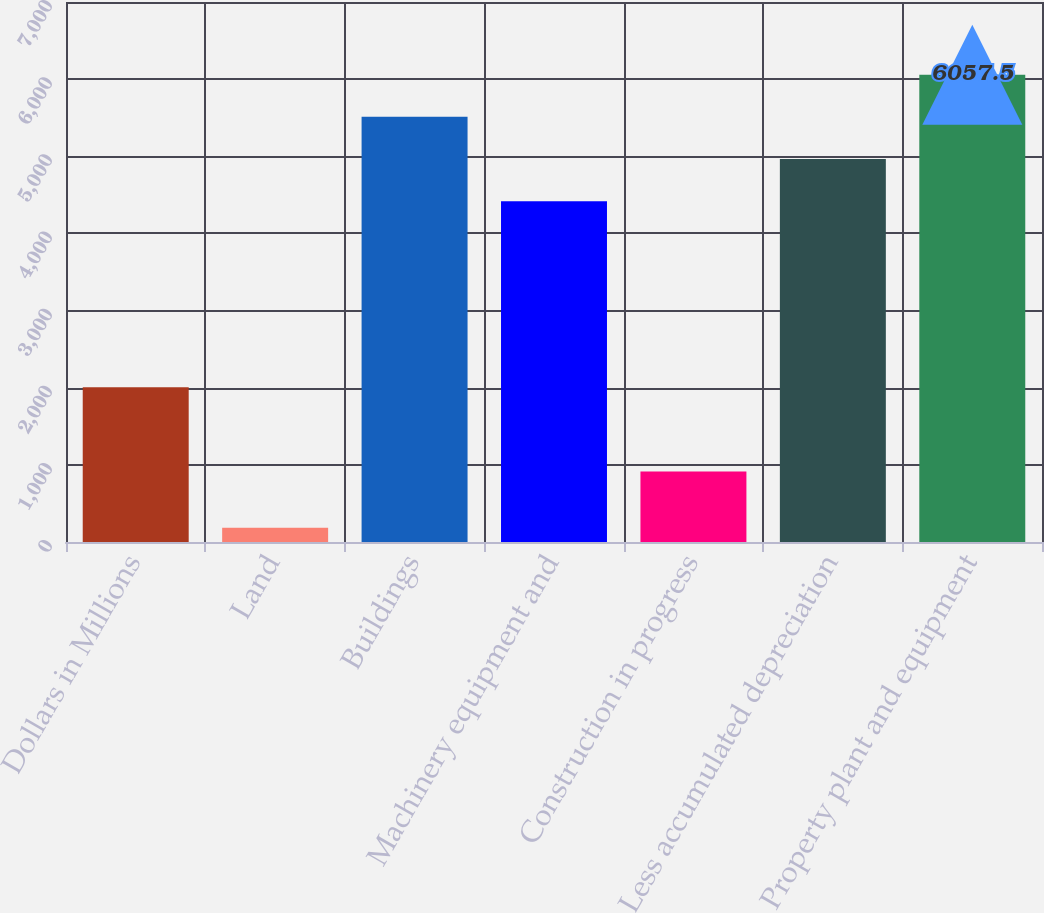Convert chart to OTSL. <chart><loc_0><loc_0><loc_500><loc_500><bar_chart><fcel>Dollars in Millions<fcel>Land<fcel>Buildings<fcel>Machinery equipment and<fcel>Construction in progress<fcel>Less accumulated depreciation<fcel>Property plant and equipment<nl><fcel>2007<fcel>185<fcel>5511<fcel>4418<fcel>915<fcel>4964.5<fcel>6057.5<nl></chart> 